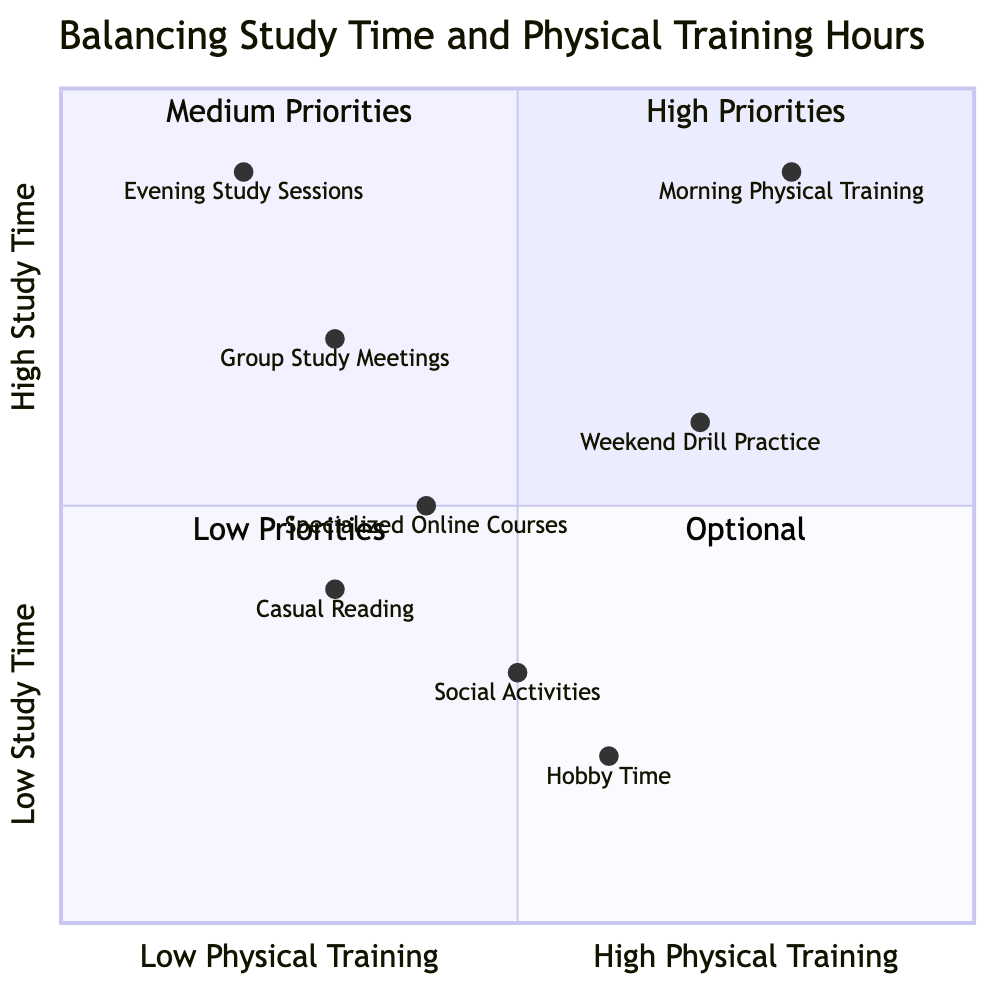What tasks are in Quadrant 1? Quadrant 1 is labeled as "High Priorities." The tasks listed under this quadrant are "Morning Physical Training" and "Evening Study Sessions."
Answer: Morning Physical Training, Evening Study Sessions How many tasks are in Quadrant 3? Quadrant 3, labeled as "Low Priorities," contains two tasks: "Casual Reading" and "Social Activities." Therefore, there are two tasks.
Answer: 2 Which task has the highest physical training hours? The task with the highest physical training hours is "Morning Physical Training," located at the coordinates [0.8, 0.9]. The high physical training score is 0.8.
Answer: Morning Physical Training What is the study time value for "Weekend Drill Practice"? "Weekend Drill Practice" has a study time value of 0.6, which is derived from its coordinates [0.7, 0.6].
Answer: 0.6 Which quadrant contains "Group Study Meetings"? "Group Study Meetings" is located in Quadrant 2, which is labeled as "Medium Priorities."
Answer: Medium Priorities Which activity has the lowest physical training hours? The task with the lowest physical training hours is "Hobby Time," which has a physical training value of 0.6, the lowest among tasks that engage in more physical training activity.
Answer: Hobby Time What is the y-axis value for "Evening Study Sessions"? The y-axis value for "Evening Study Sessions" is 0.9, indicating a high study time.
Answer: 0.9 Are there any tasks in Quadrant 4? Quadrant 4 is labeled as "Optional" and includes two tasks: "Hobby Time" and "Specialized Online Courses," indicating that there are indeed tasks listed here.
Answer: Yes Which quadrant has the lowest priorities? Quadrant 3 is labeled as "Low Priorities," indicating that it holds the lower priority tasks.
Answer: Low Priorities 